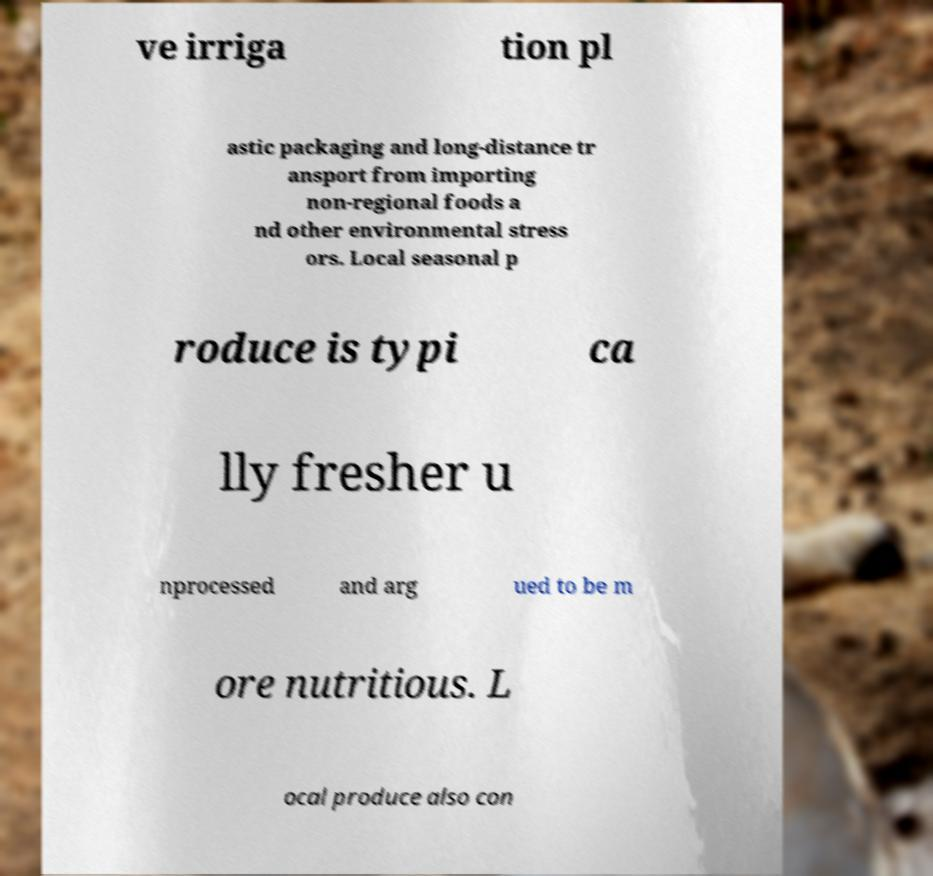I need the written content from this picture converted into text. Can you do that? ve irriga tion pl astic packaging and long-distance tr ansport from importing non-regional foods a nd other environmental stress ors. Local seasonal p roduce is typi ca lly fresher u nprocessed and arg ued to be m ore nutritious. L ocal produce also con 